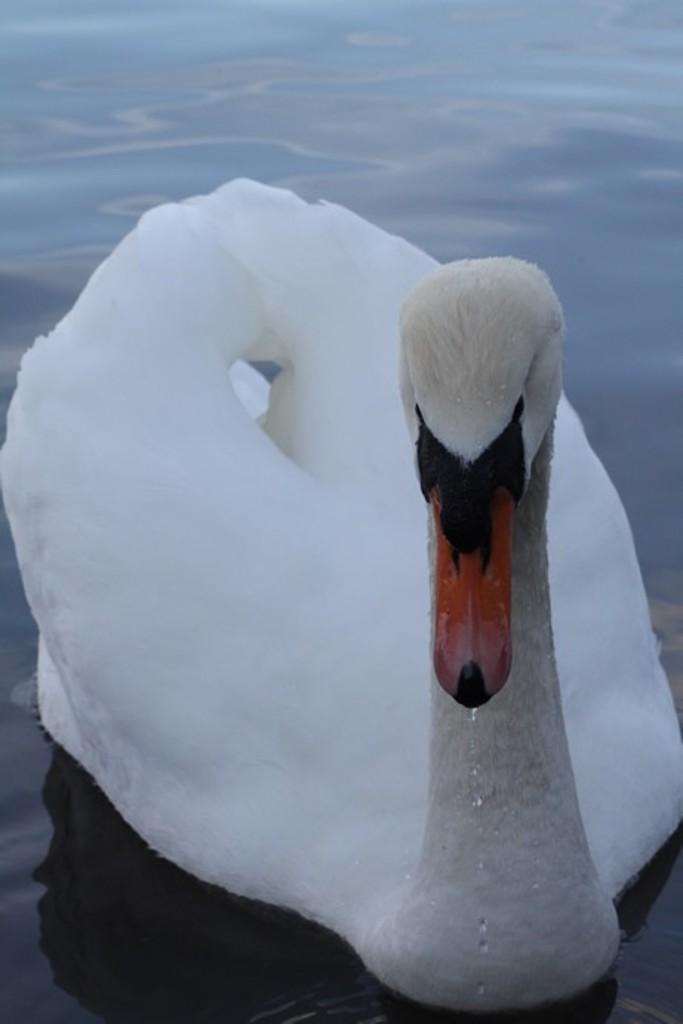What type of animal is in the image? There is a swan in the image. What is the environment in which the swan is situated? The swan is in water. What type of meat is being served at the building in the image? There is no building or meat present in the image; it features a swan in water. 